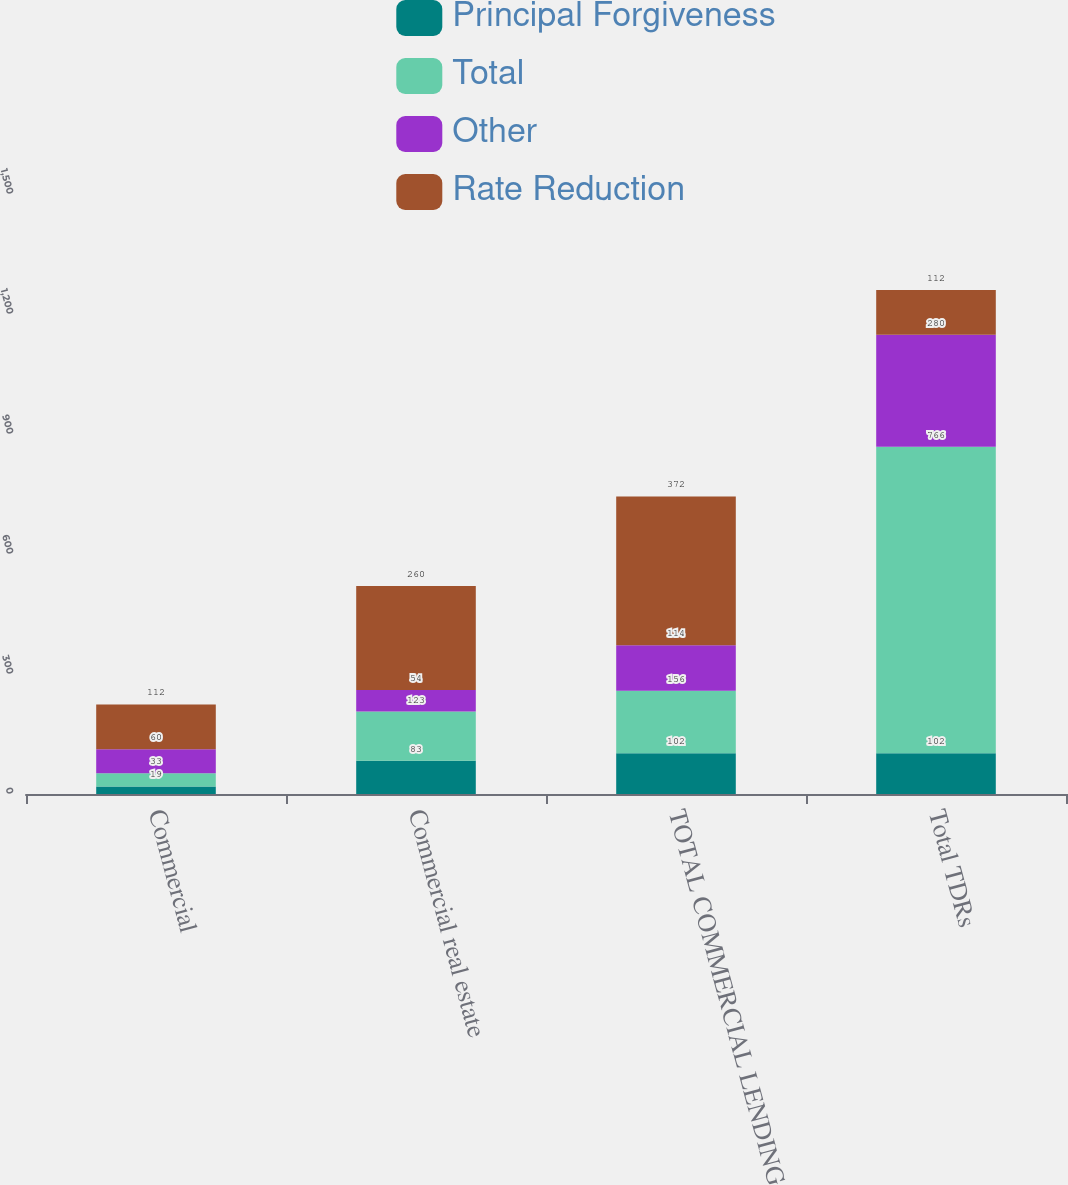Convert chart to OTSL. <chart><loc_0><loc_0><loc_500><loc_500><stacked_bar_chart><ecel><fcel>Commercial<fcel>Commercial real estate<fcel>TOTAL COMMERCIAL LENDING (a)<fcel>Total TDRs<nl><fcel>Principal Forgiveness<fcel>19<fcel>83<fcel>102<fcel>102<nl><fcel>Total<fcel>33<fcel>123<fcel>156<fcel>766<nl><fcel>Other<fcel>60<fcel>54<fcel>114<fcel>280<nl><fcel>Rate Reduction<fcel>112<fcel>260<fcel>372<fcel>112<nl></chart> 